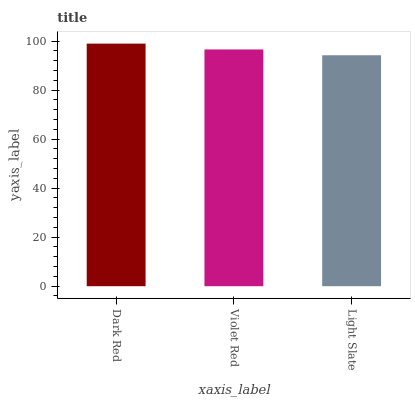Is Violet Red the minimum?
Answer yes or no. No. Is Violet Red the maximum?
Answer yes or no. No. Is Dark Red greater than Violet Red?
Answer yes or no. Yes. Is Violet Red less than Dark Red?
Answer yes or no. Yes. Is Violet Red greater than Dark Red?
Answer yes or no. No. Is Dark Red less than Violet Red?
Answer yes or no. No. Is Violet Red the high median?
Answer yes or no. Yes. Is Violet Red the low median?
Answer yes or no. Yes. Is Dark Red the high median?
Answer yes or no. No. Is Light Slate the low median?
Answer yes or no. No. 